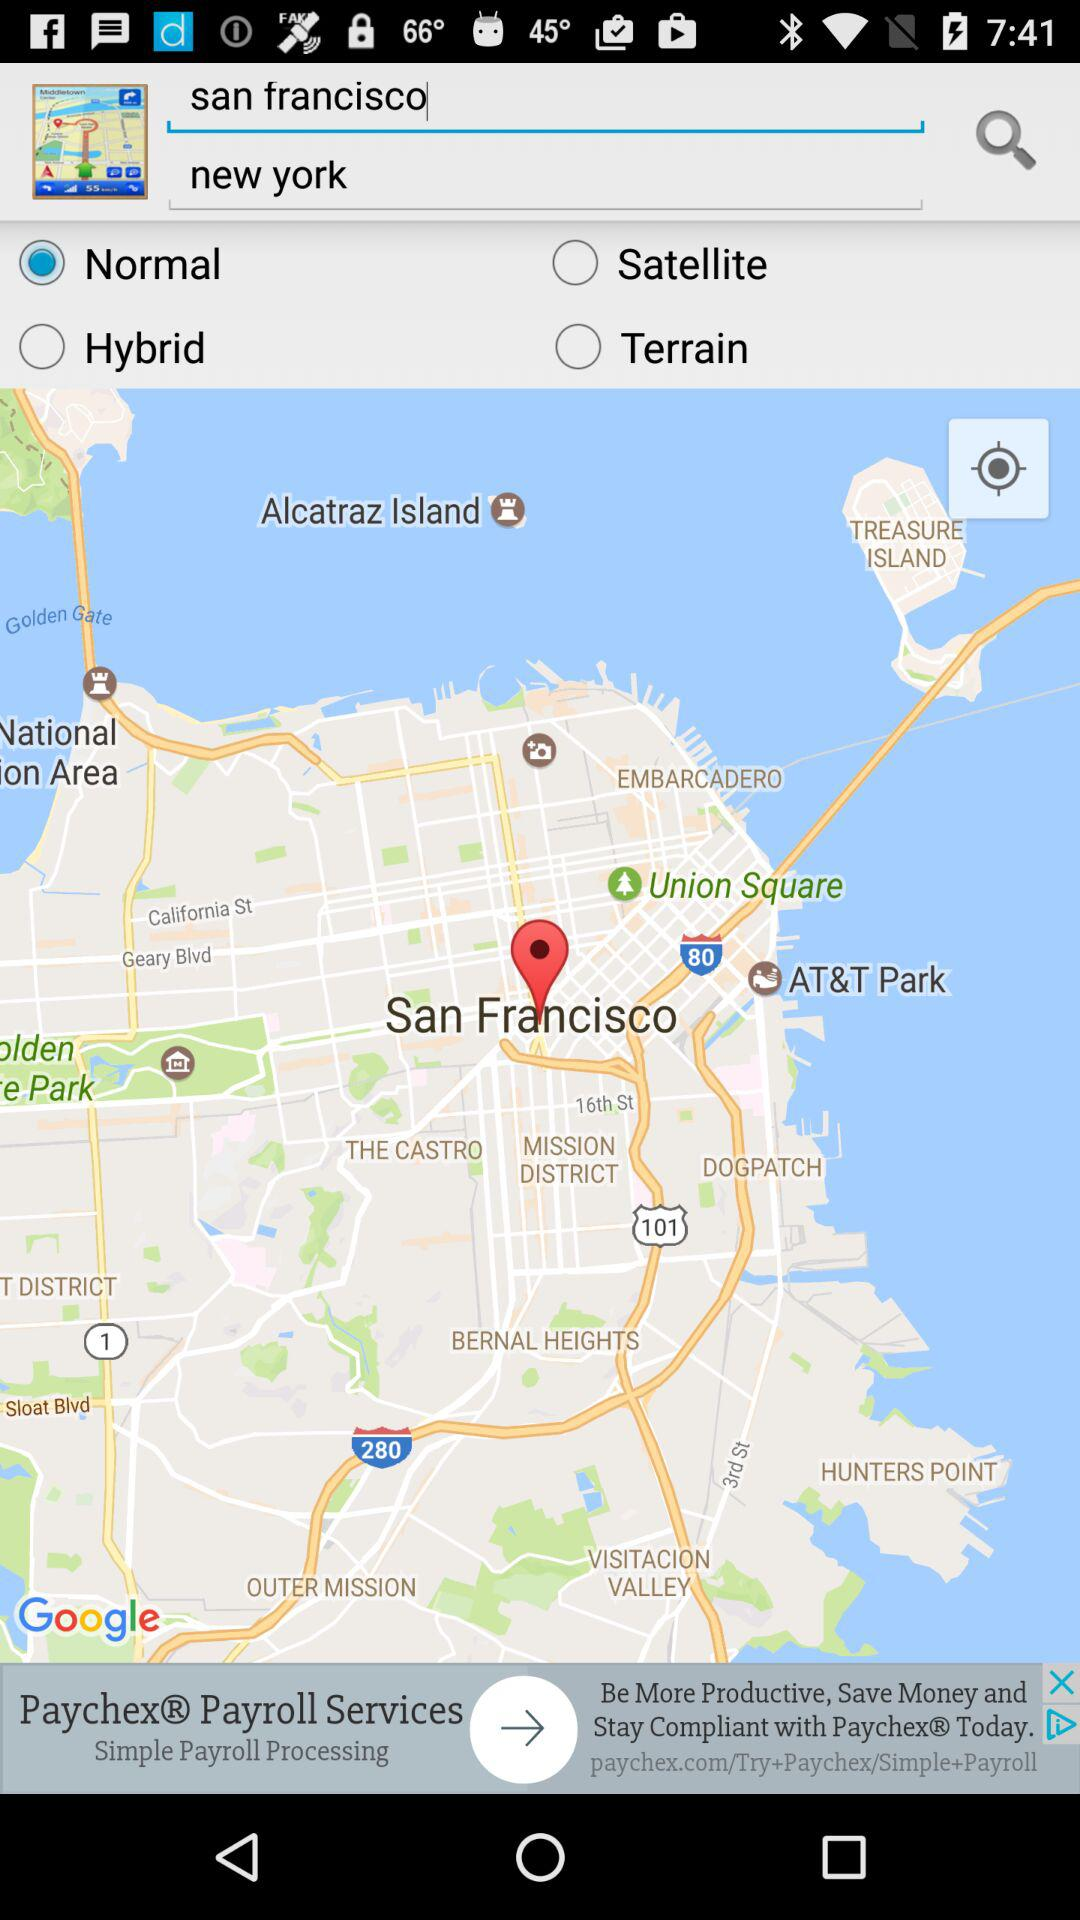What is the location? The locations are San Francisco and New York. 